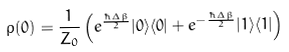Convert formula to latex. <formula><loc_0><loc_0><loc_500><loc_500>\rho ( 0 ) = \frac { 1 } { Z _ { 0 } } \left ( e ^ { \frac { \hbar { \Delta } \beta } { 2 } } | 0 \rangle \langle 0 | + e ^ { - \frac { \hbar { \Delta } \beta } { 2 } } | 1 \rangle \langle 1 | \right ) \,</formula> 